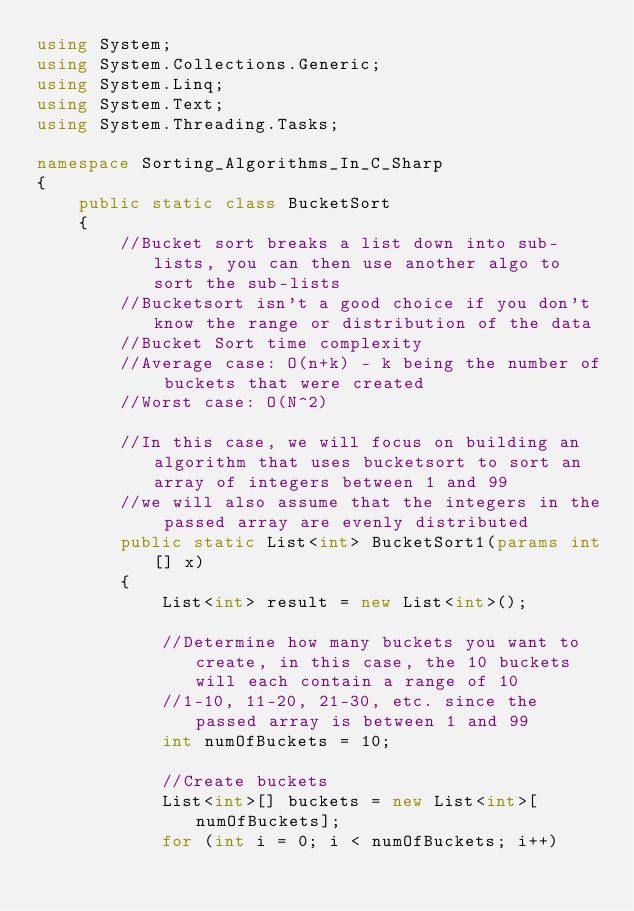<code> <loc_0><loc_0><loc_500><loc_500><_C#_>using System;
using System.Collections.Generic;
using System.Linq;
using System.Text;
using System.Threading.Tasks;
 
namespace Sorting_Algorithms_In_C_Sharp
{
    public static class BucketSort
    {
        //Bucket sort breaks a list down into sub-lists, you can then use another algo to sort the sub-lists
        //Bucketsort isn't a good choice if you don't know the range or distribution of the data
        //Bucket Sort time complexity
        //Average case: O(n+k) - k being the number of buckets that were created
        //Worst case: O(N^2)
 
        //In this case, we will focus on building an algorithm that uses bucketsort to sort an array of integers between 1 and 99
        //we will also assume that the integers in the passed array are evenly distributed
        public static List<int> BucketSort1(params int[] x)
        {
            List<int> result = new List<int>();
 
            //Determine how many buckets you want to create, in this case, the 10 buckets will each contain a range of 10
            //1-10, 11-20, 21-30, etc. since the passed array is between 1 and 99
            int numOfBuckets = 10;
 
            //Create buckets
            List<int>[] buckets = new List<int>[numOfBuckets];
            for (int i = 0; i < numOfBuckets; i++)</code> 